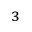<formula> <loc_0><loc_0><loc_500><loc_500>_ { 3 }</formula> 